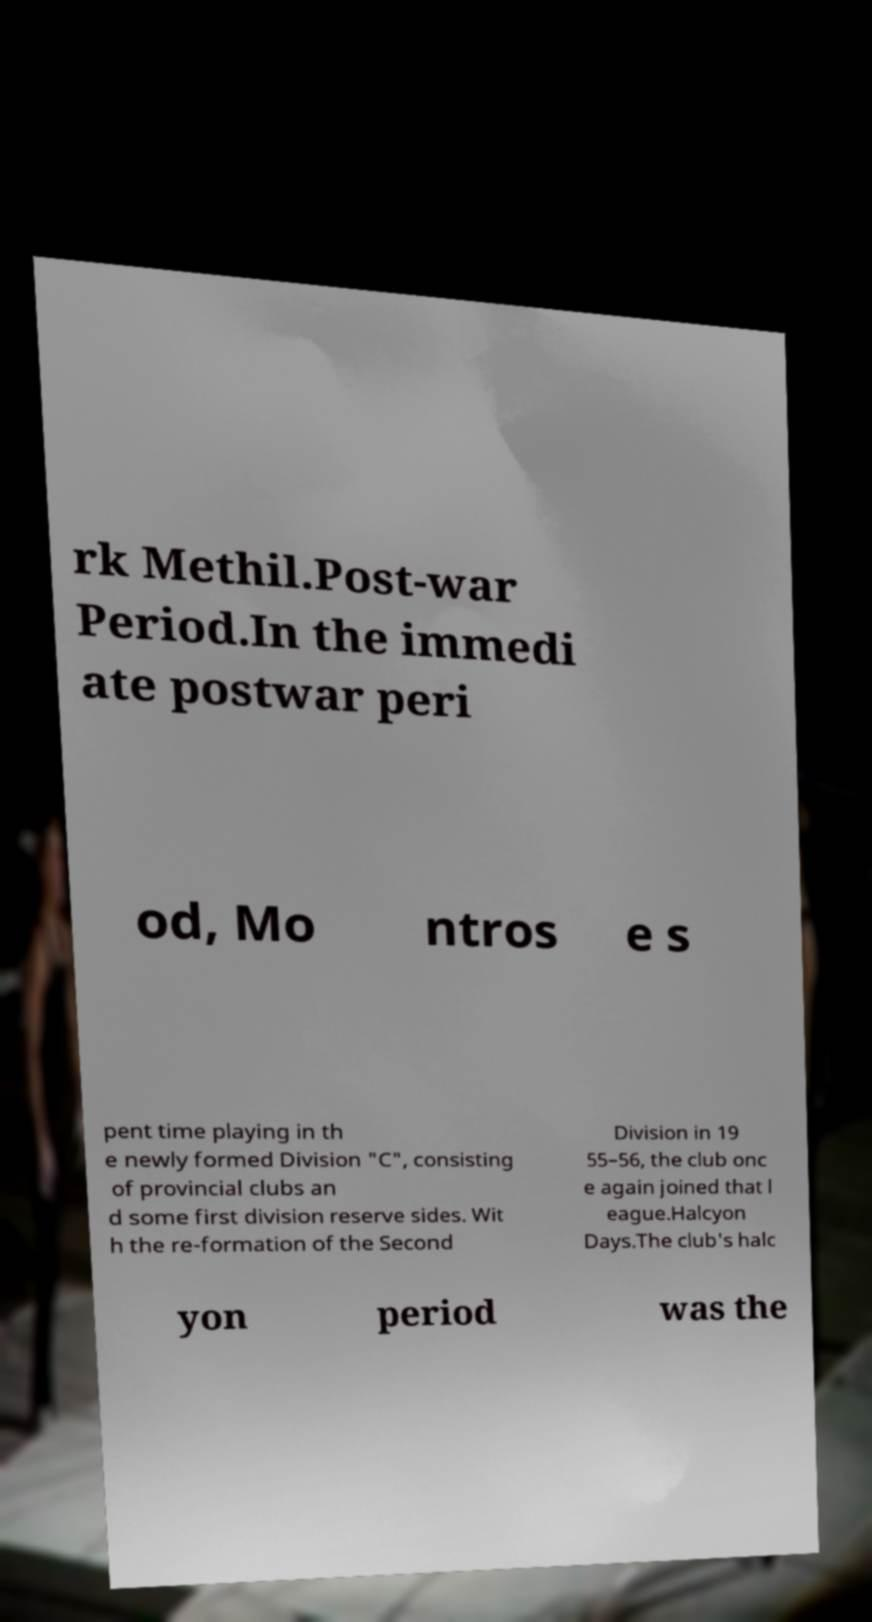What messages or text are displayed in this image? I need them in a readable, typed format. rk Methil.Post-war Period.In the immedi ate postwar peri od, Mo ntros e s pent time playing in th e newly formed Division "C", consisting of provincial clubs an d some first division reserve sides. Wit h the re-formation of the Second Division in 19 55–56, the club onc e again joined that l eague.Halcyon Days.The club's halc yon period was the 